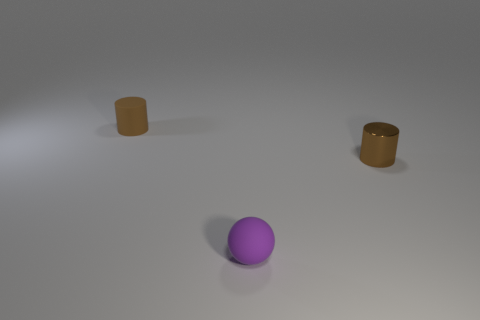Is the number of small shiny cylinders on the left side of the purple matte thing the same as the number of purple rubber objects that are right of the brown shiny cylinder? yes 